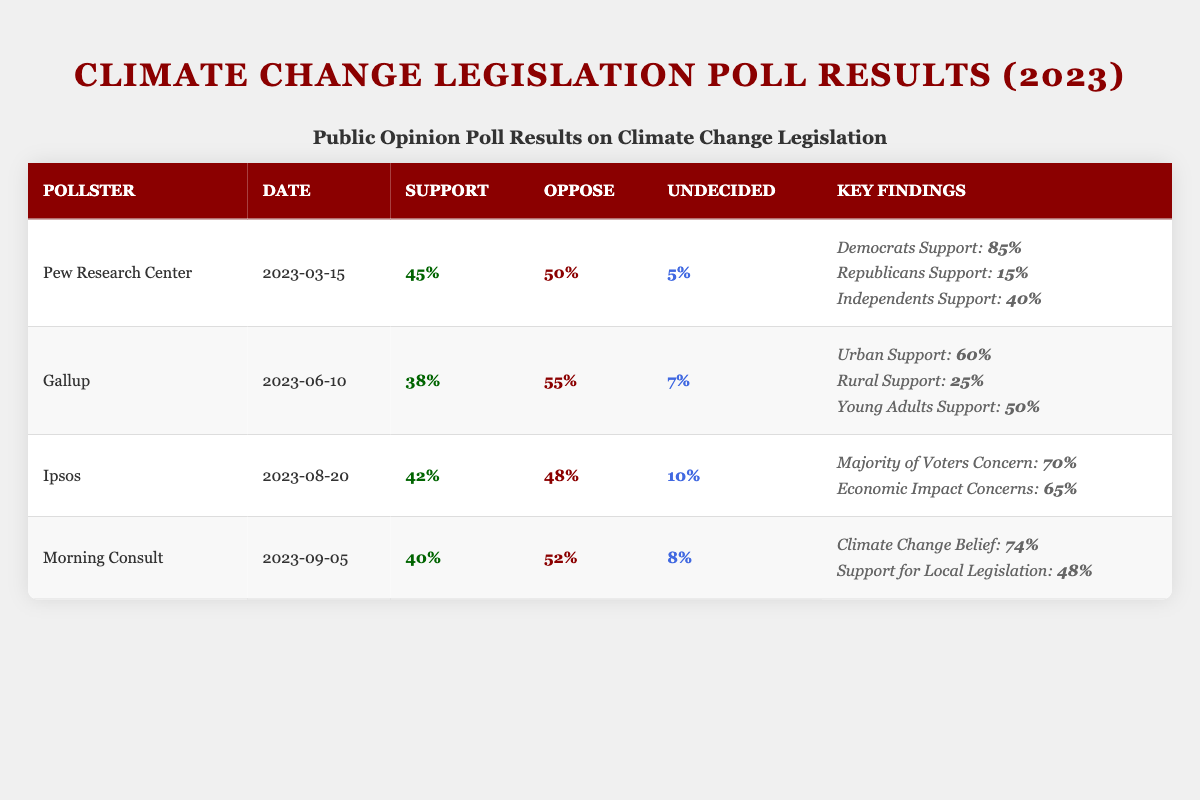What percentage of people supported climate change legislation according to the Pew Research Center? The Pew Research Center poll shows that 45% of respondents supported climate change legislation.
Answer: 45% What is the percentage of opposition to climate change legislation in the Gallup poll? The Gallup poll indicates that 55% of respondents oppose climate change legislation.
Answer: 55% Which pollster reported the highest percentage of support for climate change legislation? According to the table, the Pew Research Center reported 45%, which is the highest percentage of support among the listed pollsters.
Answer: Pew Research Center What is the total percentage of people who are undecided across all four polls? The percentage of undecided individuals is 5% (Pew) + 7% (Gallup) + 10% (Ipsos) + 8% (Morning Consult) = 30%.
Answer: 30% Is it true that the majority of voters are concerned about climate change according to the Ipsos poll? The Ipsos poll states that 70% of voters expressed concern about climate change, confirming that the majority are concerned.
Answer: Yes Which party has the lowest support for climate change legislation according to the Pew Research Center? The Pew Research Center data shows that Republicans have the lowest support at 15%.
Answer: Republicans What is the average percentage of opposition to climate change legislation across all four polls? The total percentage of opposition is 50% (Pew) + 55% (Gallup) + 48% (Ipsos) + 52% (Morning Consult) = 205%. Divide this by 4 (the number of polls) to get the average: 205% / 4 = 51.25%.
Answer: 51.25% How much greater is the support for climate change legislation among Democrats compared to Republicans according to the Pew Research Center? Democrats show 85% support and Republicans show 15% support. The difference is 85% - 15% = 70%.
Answer: 70% How many more people oppose climate change legislation than support it according to the Morning Consult poll? The Morning Consult poll shows 52% oppose and 40% support climate change legislation. The difference is 52% - 40% = 12%.
Answer: 12% In which poll did rural respondents have the least support for climate change legislation? The Gallup poll shows that rural support is at 25%, which is the lowest percentage reported across the polls.
Answer: Gallup 